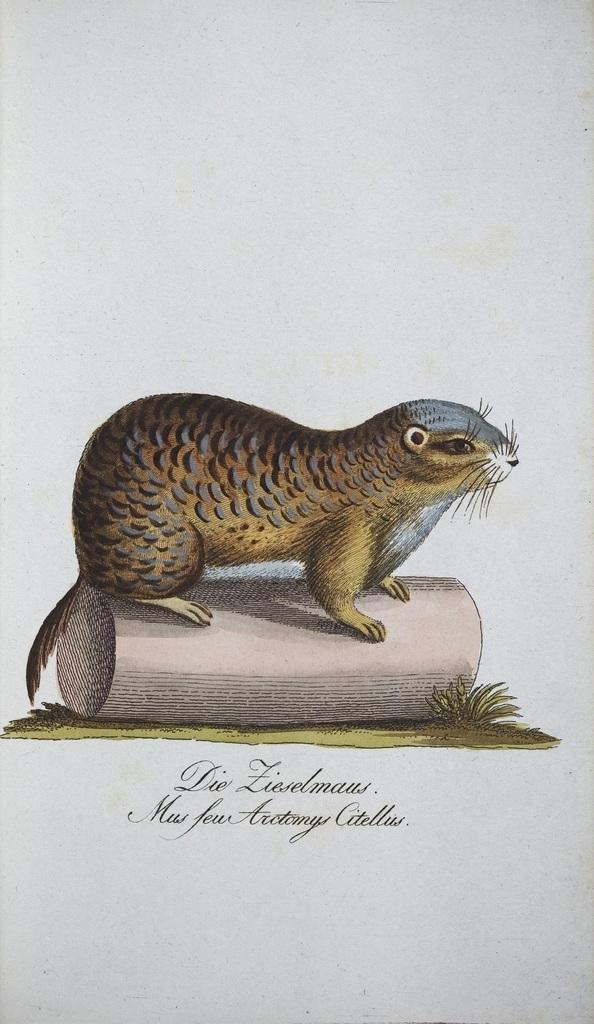What is the main subject of the image? The image contains an art piece. What animal is featured in the art piece? There is a beaver in the art piece. What is the beaver doing in the art piece? The beaver is standing on a tree in the art piece. What type of toothbrush is the beaver using in the image? There is no toothbrush present in the image. The beaver is standing on a tree in the art piece. 